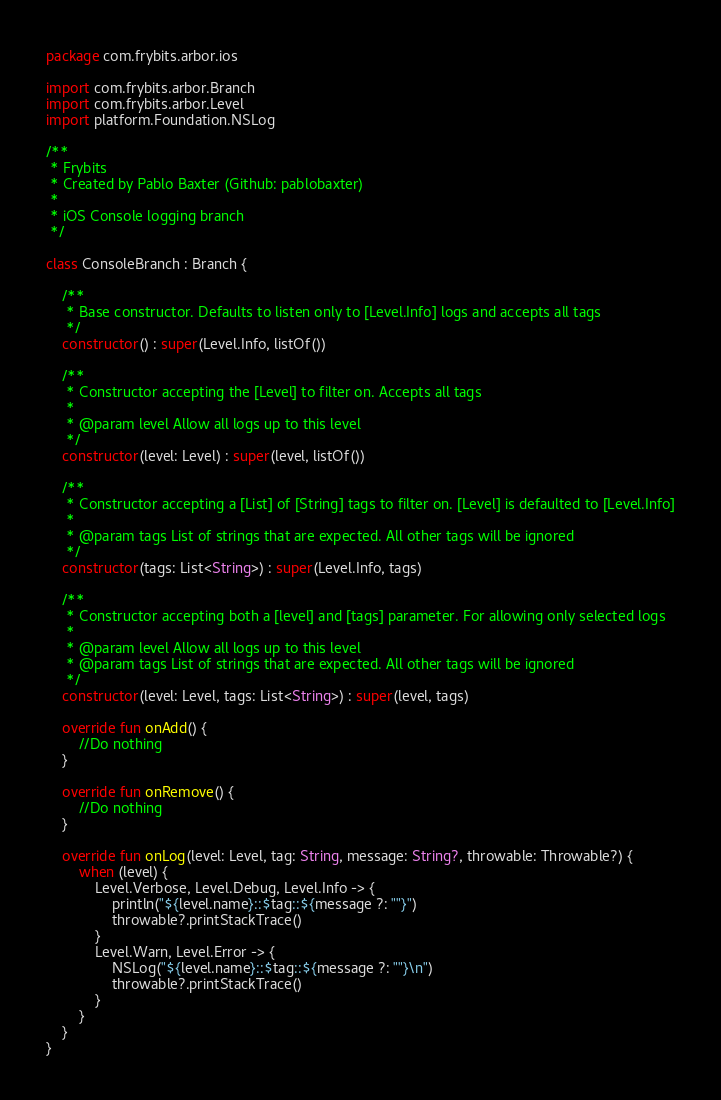Convert code to text. <code><loc_0><loc_0><loc_500><loc_500><_Kotlin_>package com.frybits.arbor.ios

import com.frybits.arbor.Branch
import com.frybits.arbor.Level
import platform.Foundation.NSLog

/**
 * Frybits
 * Created by Pablo Baxter (Github: pablobaxter)
 *
 * iOS Console logging branch
 */

class ConsoleBranch : Branch {

    /**
     * Base constructor. Defaults to listen only to [Level.Info] logs and accepts all tags
     */
    constructor() : super(Level.Info, listOf())

    /**
     * Constructor accepting the [Level] to filter on. Accepts all tags
     *
     * @param level Allow all logs up to this level
     */
    constructor(level: Level) : super(level, listOf())

    /**
     * Constructor accepting a [List] of [String] tags to filter on. [Level] is defaulted to [Level.Info]
     *
     * @param tags List of strings that are expected. All other tags will be ignored
     */
    constructor(tags: List<String>) : super(Level.Info, tags)

    /**
     * Constructor accepting both a [level] and [tags] parameter. For allowing only selected logs
     *
     * @param level Allow all logs up to this level
     * @param tags List of strings that are expected. All other tags will be ignored
     */
    constructor(level: Level, tags: List<String>) : super(level, tags)

    override fun onAdd() {
        //Do nothing
    }

    override fun onRemove() {
        //Do nothing
    }

    override fun onLog(level: Level, tag: String, message: String?, throwable: Throwable?) {
        when (level) {
            Level.Verbose, Level.Debug, Level.Info -> {
                println("${level.name}::$tag::${message ?: ""}")
                throwable?.printStackTrace()
            }
            Level.Warn, Level.Error -> {
                NSLog("${level.name}::$tag::${message ?: ""}\n")
                throwable?.printStackTrace()
            }
        }
    }
}
</code> 